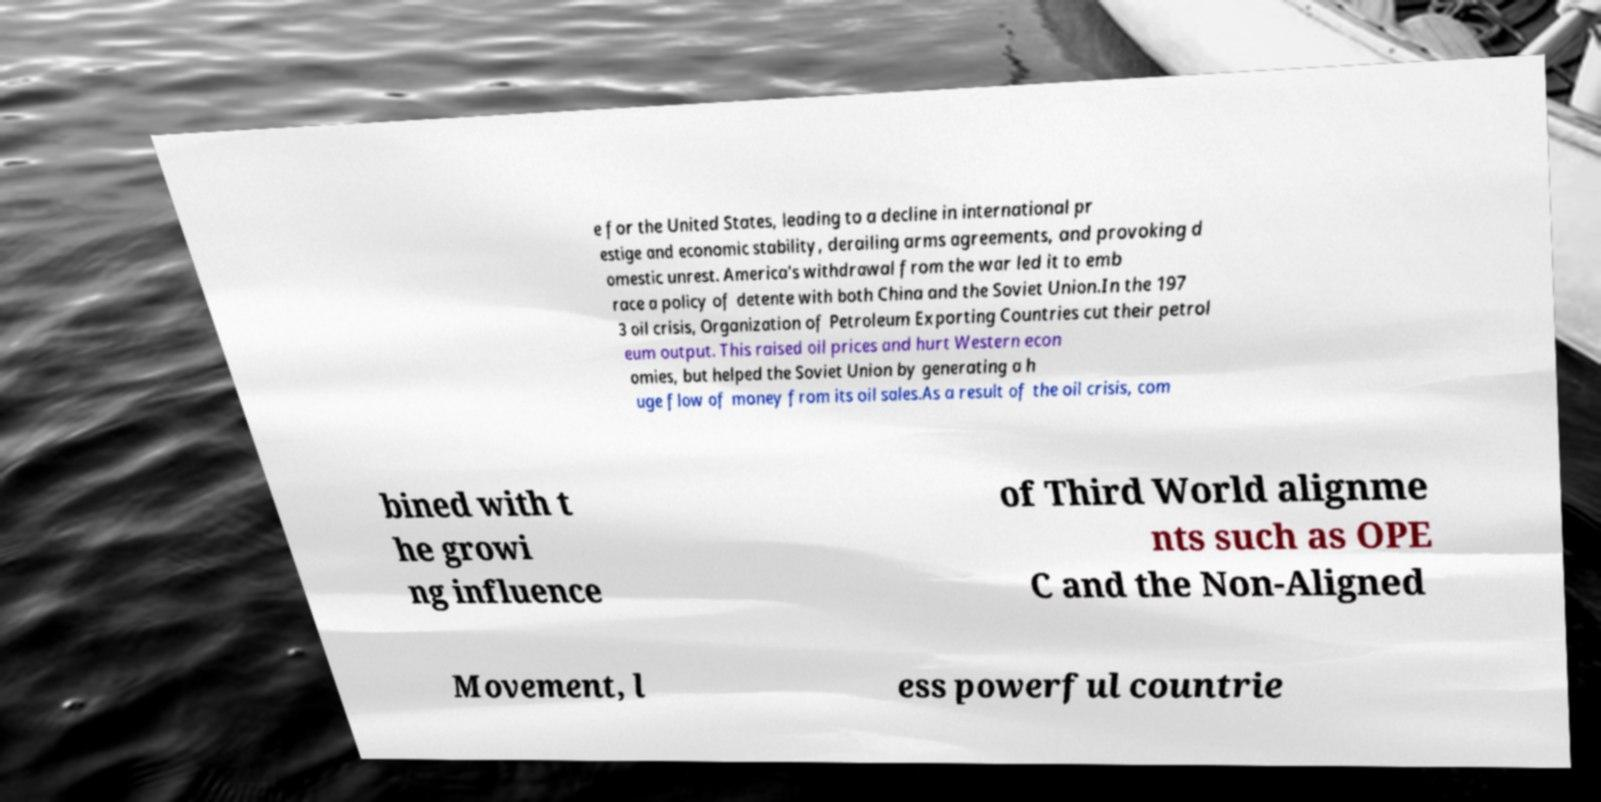I need the written content from this picture converted into text. Can you do that? e for the United States, leading to a decline in international pr estige and economic stability, derailing arms agreements, and provoking d omestic unrest. America's withdrawal from the war led it to emb race a policy of detente with both China and the Soviet Union.In the 197 3 oil crisis, Organization of Petroleum Exporting Countries cut their petrol eum output. This raised oil prices and hurt Western econ omies, but helped the Soviet Union by generating a h uge flow of money from its oil sales.As a result of the oil crisis, com bined with t he growi ng influence of Third World alignme nts such as OPE C and the Non-Aligned Movement, l ess powerful countrie 